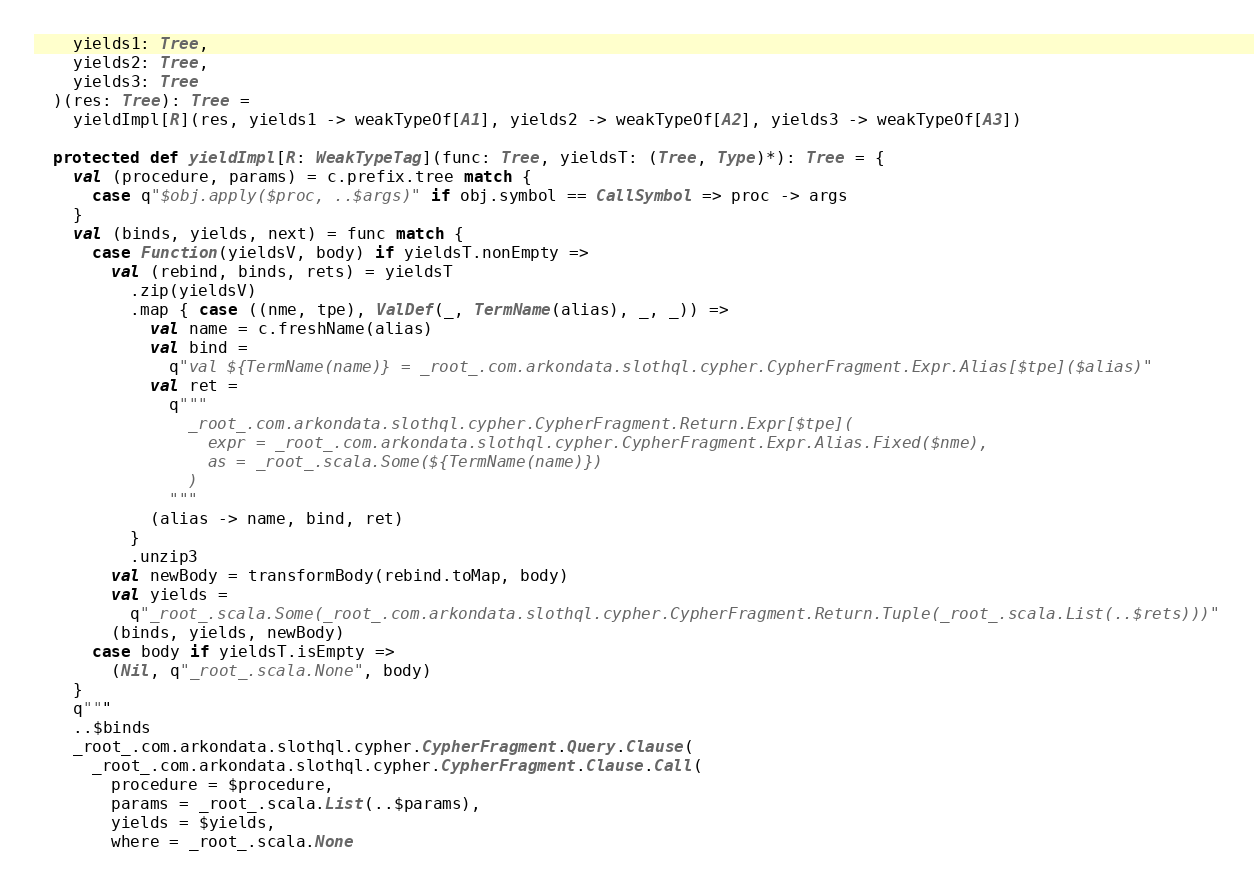<code> <loc_0><loc_0><loc_500><loc_500><_Scala_>    yields1: Tree,
    yields2: Tree,
    yields3: Tree
  )(res: Tree): Tree =
    yieldImpl[R](res, yields1 -> weakTypeOf[A1], yields2 -> weakTypeOf[A2], yields3 -> weakTypeOf[A3])

  protected def yieldImpl[R: WeakTypeTag](func: Tree, yieldsT: (Tree, Type)*): Tree = {
    val (procedure, params) = c.prefix.tree match {
      case q"$obj.apply($proc, ..$args)" if obj.symbol == CallSymbol => proc -> args
    }
    val (binds, yields, next) = func match {
      case Function(yieldsV, body) if yieldsT.nonEmpty =>
        val (rebind, binds, rets) = yieldsT
          .zip(yieldsV)
          .map { case ((nme, tpe), ValDef(_, TermName(alias), _, _)) =>
            val name = c.freshName(alias)
            val bind =
              q"val ${TermName(name)} = _root_.com.arkondata.slothql.cypher.CypherFragment.Expr.Alias[$tpe]($alias)"
            val ret =
              q"""
                _root_.com.arkondata.slothql.cypher.CypherFragment.Return.Expr[$tpe](
                  expr = _root_.com.arkondata.slothql.cypher.CypherFragment.Expr.Alias.Fixed($nme),
                  as = _root_.scala.Some(${TermName(name)})
                )
              """
            (alias -> name, bind, ret)
          }
          .unzip3
        val newBody = transformBody(rebind.toMap, body)
        val yields =
          q"_root_.scala.Some(_root_.com.arkondata.slothql.cypher.CypherFragment.Return.Tuple(_root_.scala.List(..$rets)))"
        (binds, yields, newBody)
      case body if yieldsT.isEmpty =>
        (Nil, q"_root_.scala.None", body)
    }
    q"""
    ..$binds
    _root_.com.arkondata.slothql.cypher.CypherFragment.Query.Clause(
      _root_.com.arkondata.slothql.cypher.CypherFragment.Clause.Call(
        procedure = $procedure,
        params = _root_.scala.List(..$params),
        yields = $yields,
        where = _root_.scala.None</code> 